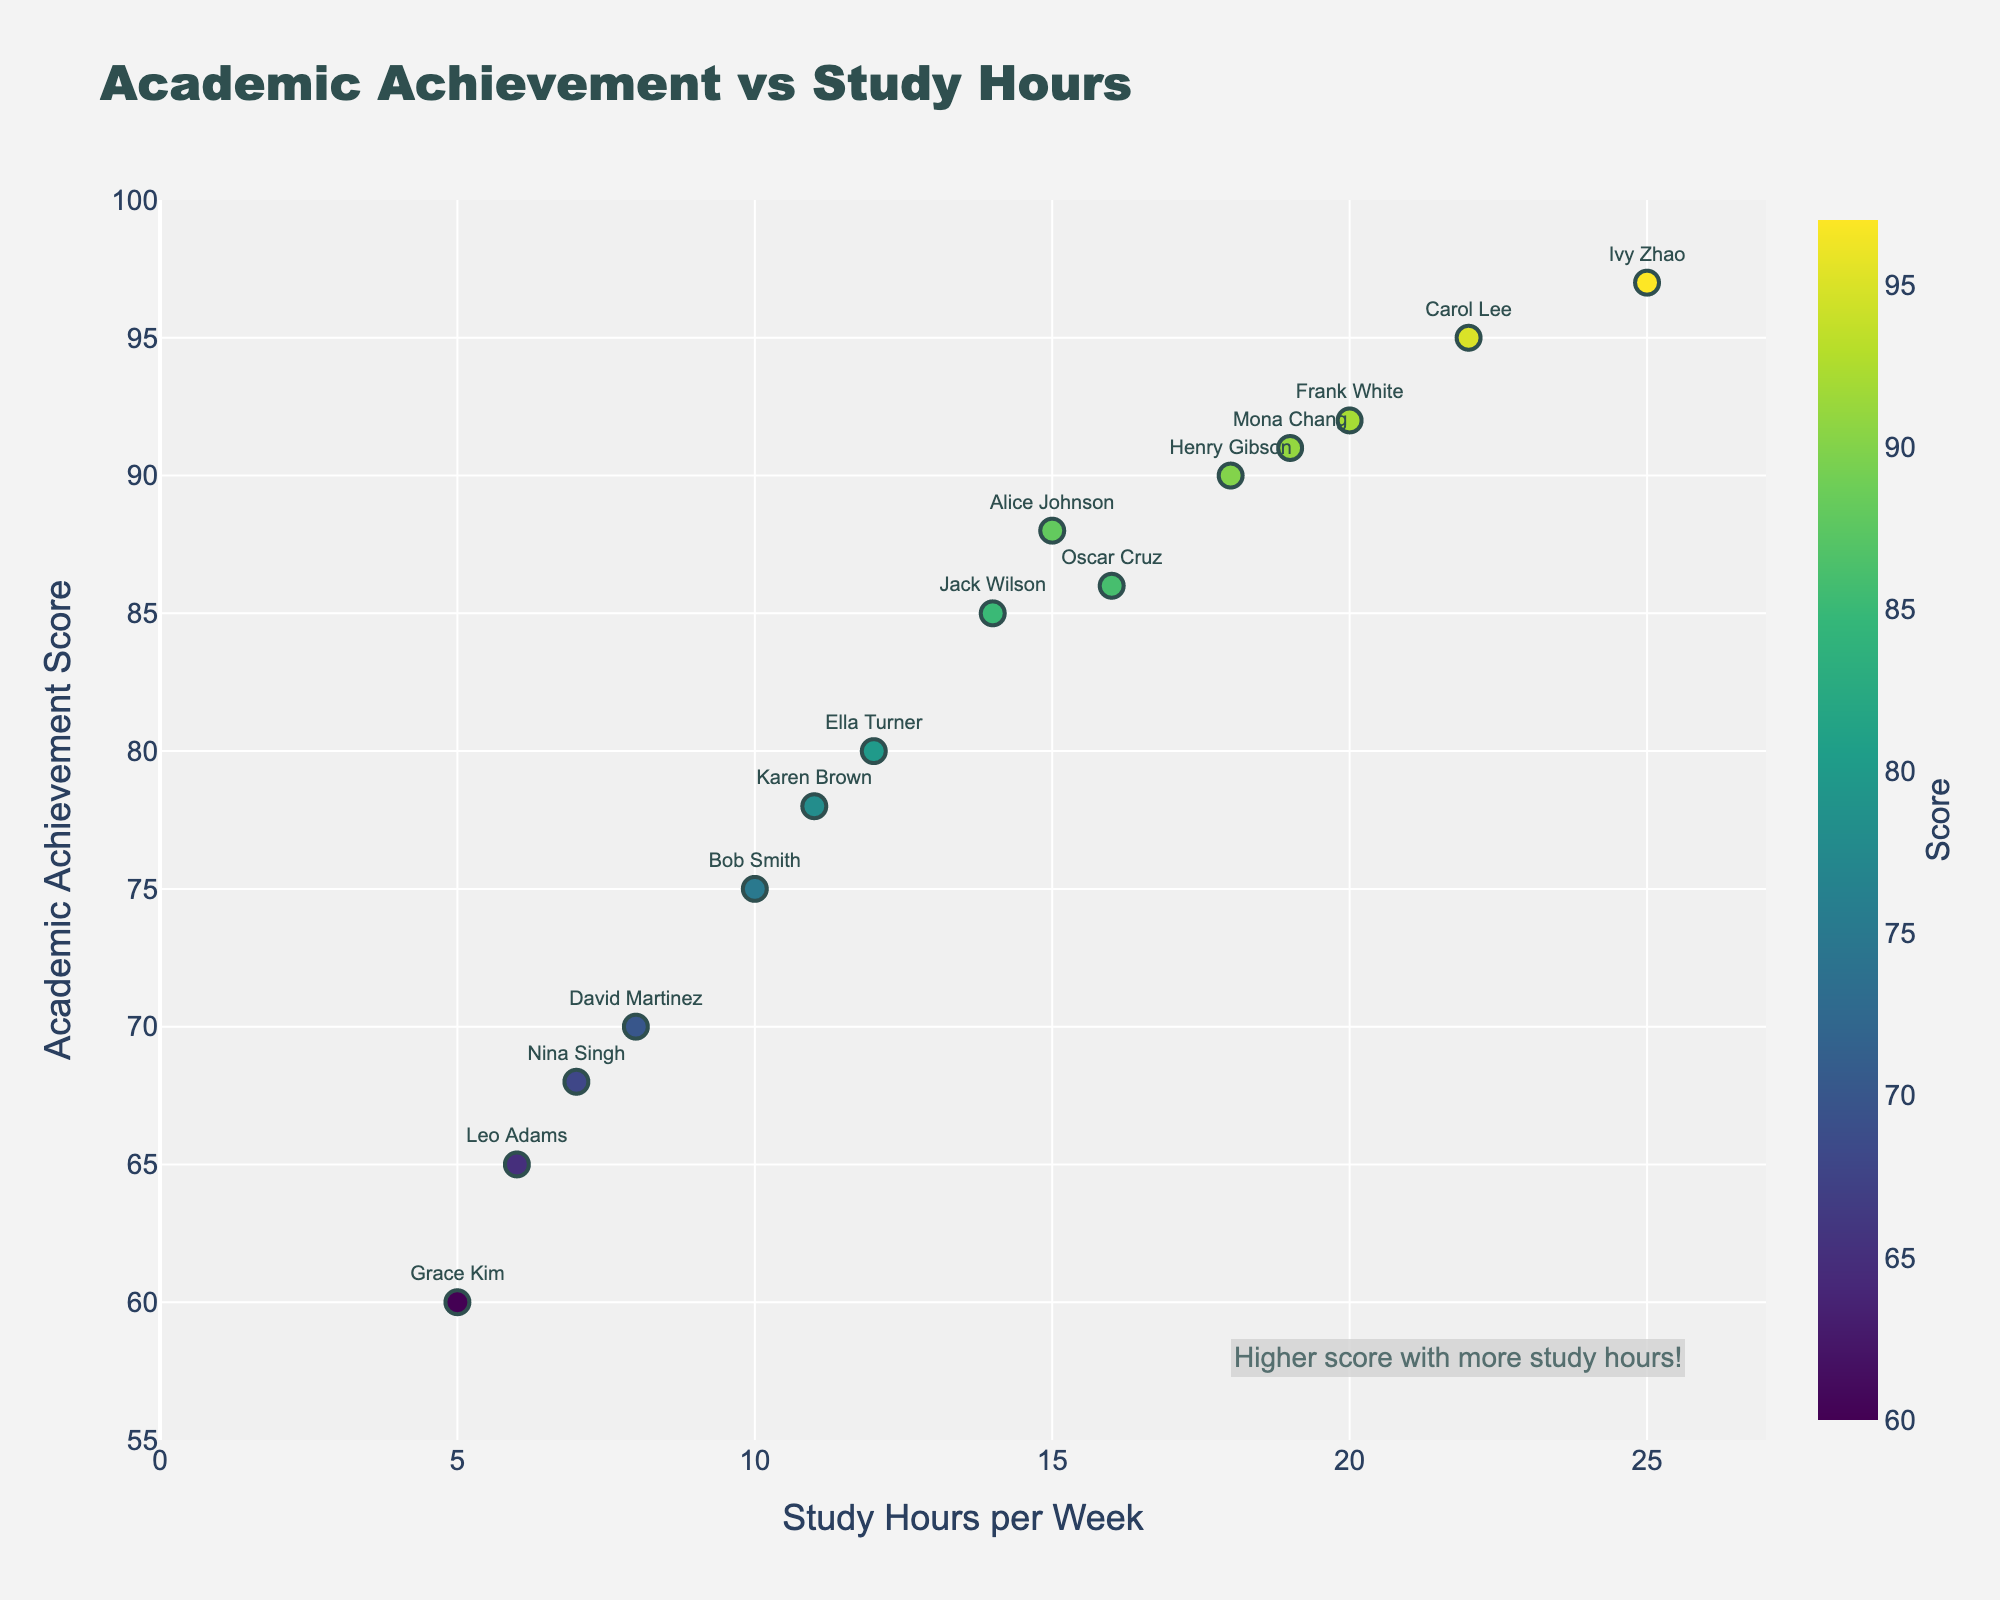What is the title of the scatter plot? The title is usually displayed at the top of the scatter plot and summarizes the main focus of the plot.
Answer: Academic Achievement vs Study Hours How many students are represented in the scatter plot? The number of data points (markers) in the scatter plot represents the number of students. By counting each marker, we can see there are 15 data points.
Answer: 15 What is the range of Study Hours per Week shown on the x-axis? By examining the x-axis labels, we can see the minimum and maximum values. The range starts slightly before 0 and ends a little over 25.
Answer: [0, 27] Which student has the highest Academic Achievement score? By finding the data point with the highest y-value, we see Ivy Zhao has the highest score, as shown in the plot.
Answer: Ivy Zhao What is the Academic Achievement of David Martinez? We locate the data point labeled as "David Martinez" and see its y-axis value.
Answer: 70 Who studies the least and what is their Academic Achievement score? The data point at the lowest value on the x-axis corresponds to Grace Kim with 5 study hours per week and her Academic Achievement score is associated with this point.
Answer: Grace Kim, 60 What is the median study hours of the students represented in the scatter plot? To find the median, we list all 'Study Hours' values in ascending order: 5, 6, 7, 8, 10, 11, 12, 14, 15, 16, 18, 19, 20, 22, 25. The middle value (8th in the list) is 14.
Answer: 14 Which two students have nearly the same academic achievement but different study hours? Look for data points at the same y-value but different x-values. Jack Wilson (14 hours, 85) and Alice Johnson (15 hours, 88) are close.
Answer: Jack Wilson and Alice Johnson What is the average Academic Achievement score of the students? Sum all Academic Achievement scores and divide by the number of students: (88+75+95+70+80+92+60+90+97+85+78+65+91+68+86) / 15 = 80.8
Answer: 80.8 For students who study more than 15 hours per week, what's the average Academic Achievement score? Include only the students with more than 15 study hours: (Carol Lee, Frank White, Henry Gibson, Ivy Zhao, Mona Chang). Sum their academic scores and divide by the number of these students: (95+92+90+97+91) / 5 = 93
Answer: 93 